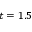<formula> <loc_0><loc_0><loc_500><loc_500>t = 1 . 5</formula> 